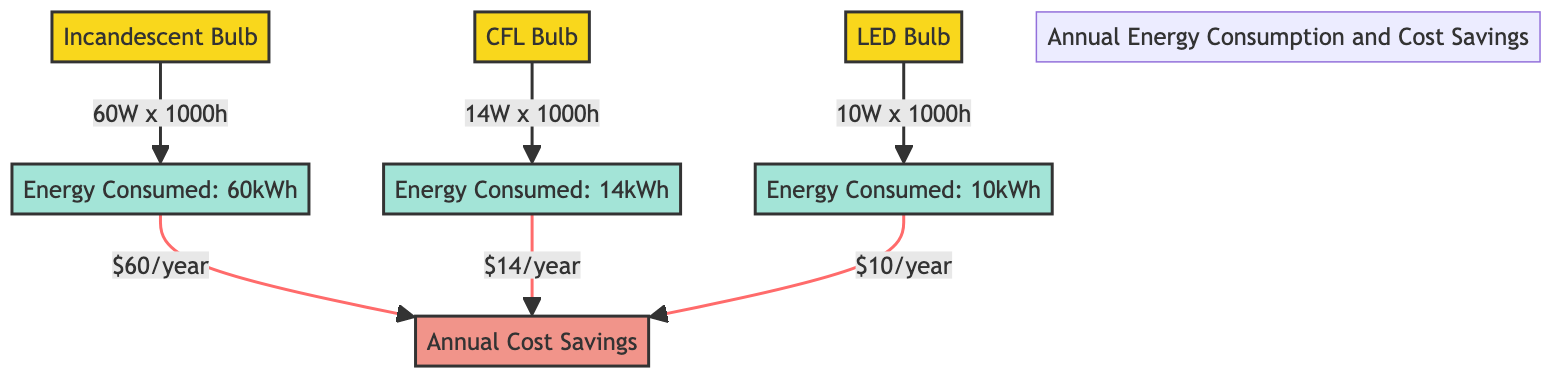What is the energy consumed by an incandescent bulb? The diagram shows that the incandescent bulb consumes 60 kWh of energy. This is directly indicated under the node labeled "Energy Consumed: 60kWh."
Answer: 60 kWh What is the annual cost savings for using an LED bulb? The LED bulb yields an annual cost savings of $10, which is stated in the node connected to the energy consumed by the LED bulb.
Answer: $10 Which bulb consumes the least energy? Based on the diagram, the LED bulb consumes the least energy at 10 kWh, as shown under its respective energy consumed node.
Answer: LED bulb How much energy does a CFL bulb consume annually? The diagram specifies that the CFL bulb consumes 14 kWh of energy, detailed under its own energy consumed node.
Answer: 14 kWh What is the total number of bulbs represented in the diagram? There are three bulbs represented in the diagram: incandescent, CFL, and LED. This can be counted from the nodes on the left side of the diagram.
Answer: Three Which bulb offers the highest annual cost savings? Reasoning through the diagram, the incandescent bulb provides the highest annual cost savings of $60, as indicated in the node connected to its energy consumption.
Answer: Incandescent bulb How much energy is consumed by a CFL bulb compared to an LED bulb? The diagram indicates that the CFL bulb consumes 14 kWh, while the LED bulb consumes 10 kWh; thus, the CFL bulb consumes 4 kWh more than the LED bulb.
Answer: 4 kWh more What is the relationship between energy consumption and cost savings for incandescent bulbs? The diagram links the energy consumption (60 kWh) of the incandescent bulbs directly to an annual cost saving of $60. This reflects a direct relationship between higher energy use and higher cost savings.
Answer: Direct relationship How many energy consumption nodes are represented in the diagram? There are three energy consumption nodes, one for each type of bulb: incandescent, CFL, and LED. This can be verified by counting the nodes specifically labeled for energy consumption.
Answer: Three 